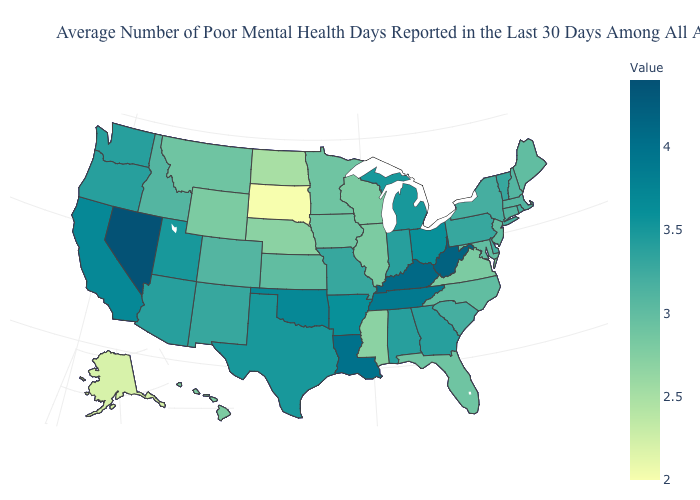Among the states that border Arizona , which have the lowest value?
Write a very short answer. Colorado. Among the states that border Nevada , does Idaho have the lowest value?
Keep it brief. Yes. Which states have the lowest value in the USA?
Concise answer only. South Dakota. Among the states that border Michigan , does Wisconsin have the highest value?
Quick response, please. No. Among the states that border Montana , does South Dakota have the lowest value?
Be succinct. Yes. Among the states that border Alabama , which have the lowest value?
Answer briefly. Mississippi. Is the legend a continuous bar?
Keep it brief. Yes. 